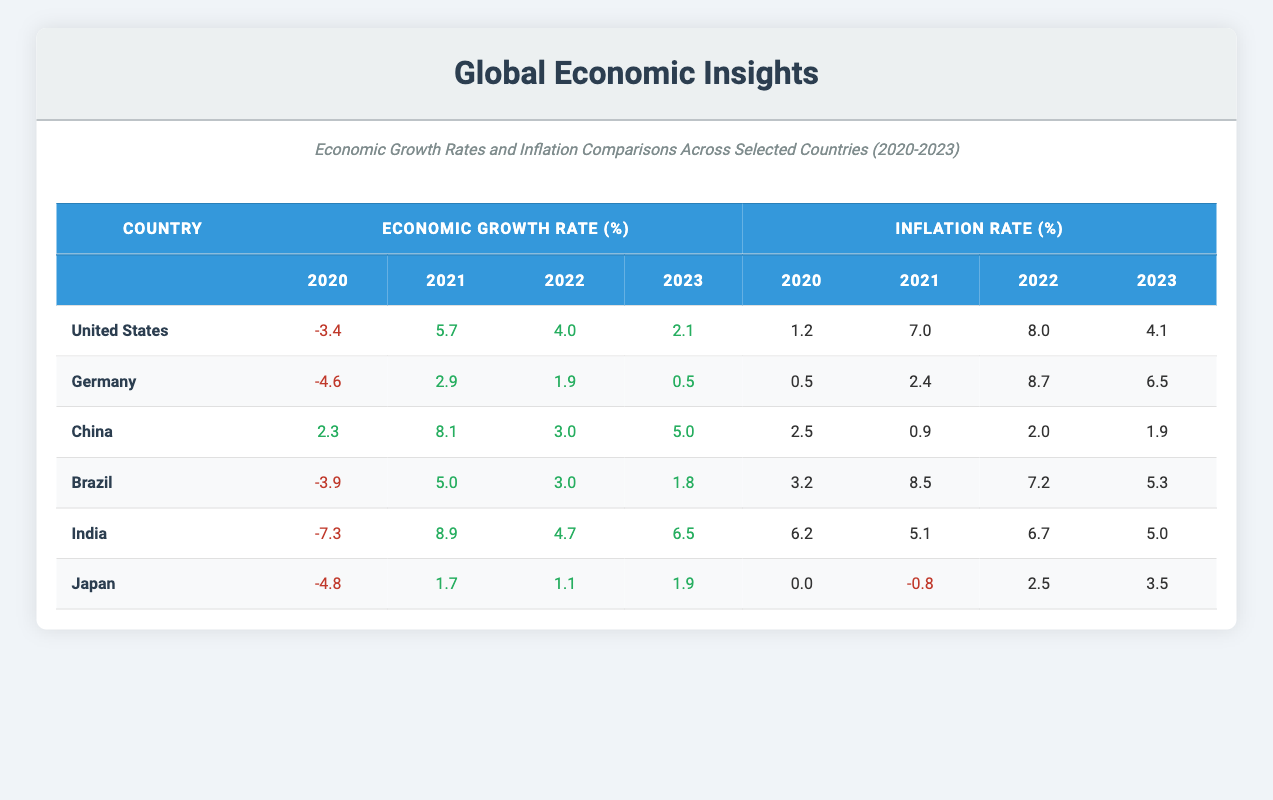What was the economic growth rate of India in 2021? The economic growth rate of India in 2021 is -7.3%. This value can be found directly under the 2021 column for India's economic growth rate in the table.
Answer: 8.9 Which country had the highest inflation rate in 2022? To find the highest inflation rate in 2022, we compare the inflation rates across all countries for that year. The values are 8.0 (US), 8.7 (Germany), 2.0 (China), 7.2 (Brazil), 6.7 (India), and 2.5 (Japan). Germany's inflation rate of 8.7% is the highest.
Answer: 8.7 What is the average economic growth rate of the United States from 2020 to 2023? To calculate the average economic growth rate for the United States, we sum the rates: -3.4 + 5.7 + 4.0 + 2.1 = 8.4. Then, we divide by the number of years (4). Hence, the average is 8.4/4 = 2.1%.
Answer: 2.1 True or False: Japan had a positive economic growth rate in 2020. By looking at the table, Japan's economic growth rate for 2020 is -4.8%, which is negative. Therefore, the statement is false.
Answer: False Which country showed consistent positive economic growth rates from 2020 to 2023? To determine this, we examine the economic growth rates for each country. China is the only country with all positive values: 2.3% (2020), 8.1% (2021), 3.0% (2022), and 5.0% (2023). This makes China the only country with consistent positive growth rates in that period.
Answer: China 